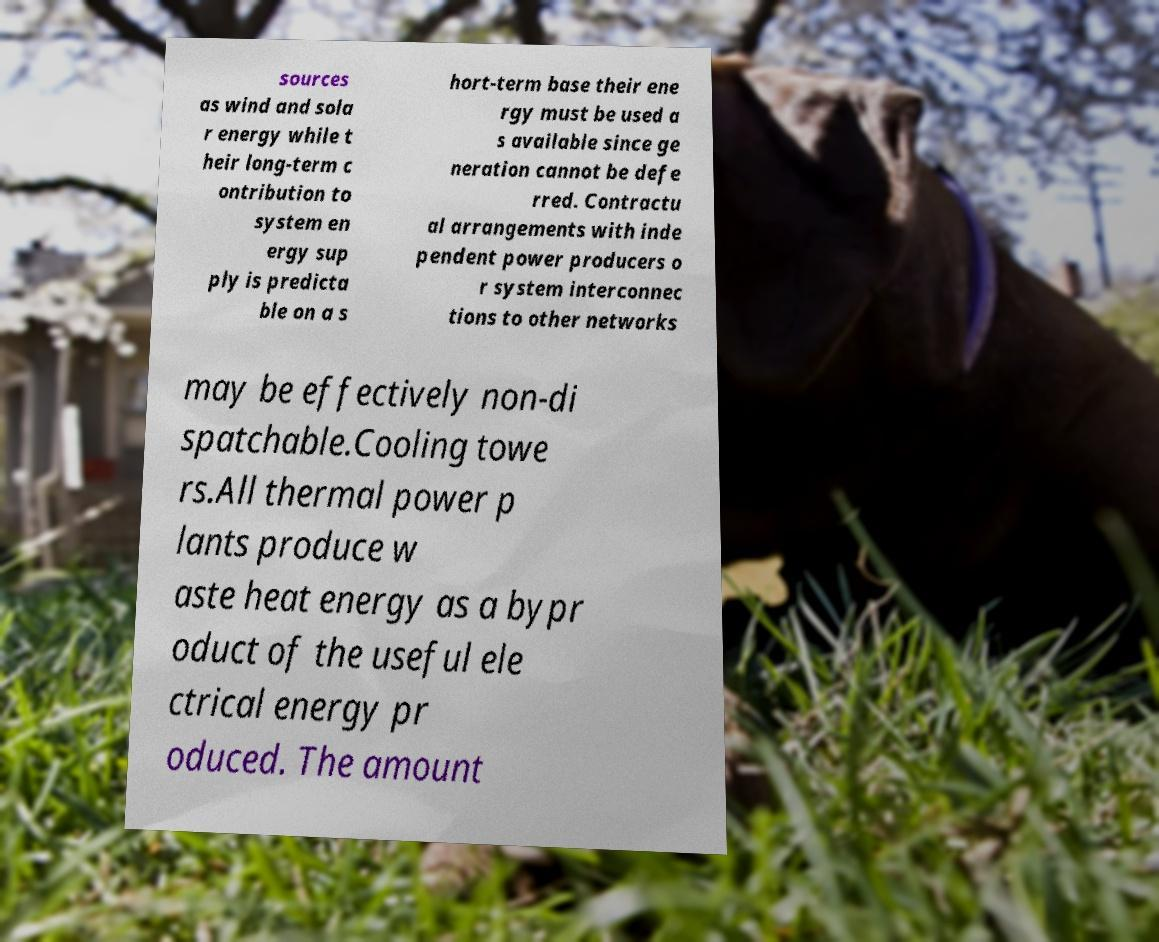Could you assist in decoding the text presented in this image and type it out clearly? sources as wind and sola r energy while t heir long-term c ontribution to system en ergy sup ply is predicta ble on a s hort-term base their ene rgy must be used a s available since ge neration cannot be defe rred. Contractu al arrangements with inde pendent power producers o r system interconnec tions to other networks may be effectively non-di spatchable.Cooling towe rs.All thermal power p lants produce w aste heat energy as a bypr oduct of the useful ele ctrical energy pr oduced. The amount 